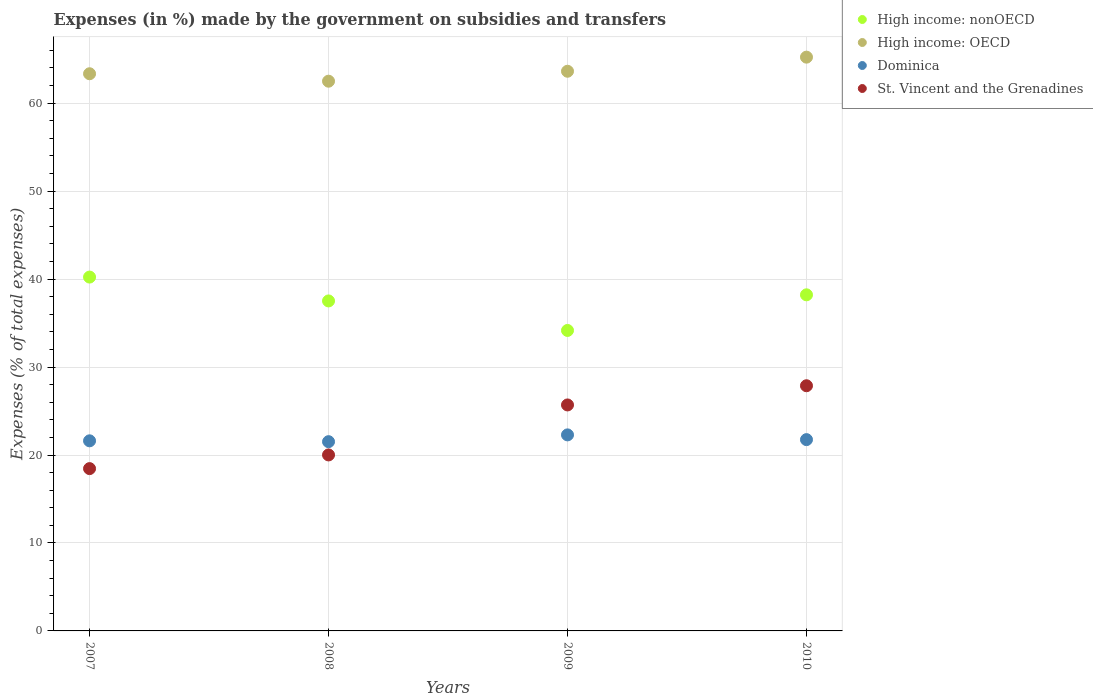What is the percentage of expenses made by the government on subsidies and transfers in St. Vincent and the Grenadines in 2010?
Your response must be concise. 27.87. Across all years, what is the maximum percentage of expenses made by the government on subsidies and transfers in High income: nonOECD?
Provide a succinct answer. 40.23. Across all years, what is the minimum percentage of expenses made by the government on subsidies and transfers in St. Vincent and the Grenadines?
Give a very brief answer. 18.45. In which year was the percentage of expenses made by the government on subsidies and transfers in High income: nonOECD minimum?
Your answer should be compact. 2009. What is the total percentage of expenses made by the government on subsidies and transfers in High income: OECD in the graph?
Your answer should be very brief. 254.71. What is the difference between the percentage of expenses made by the government on subsidies and transfers in High income: OECD in 2007 and that in 2008?
Provide a short and direct response. 0.85. What is the difference between the percentage of expenses made by the government on subsidies and transfers in Dominica in 2009 and the percentage of expenses made by the government on subsidies and transfers in High income: OECD in 2007?
Offer a terse response. -41.06. What is the average percentage of expenses made by the government on subsidies and transfers in High income: nonOECD per year?
Provide a succinct answer. 37.53. In the year 2007, what is the difference between the percentage of expenses made by the government on subsidies and transfers in High income: nonOECD and percentage of expenses made by the government on subsidies and transfers in Dominica?
Your answer should be compact. 18.62. In how many years, is the percentage of expenses made by the government on subsidies and transfers in High income: nonOECD greater than 64 %?
Your answer should be compact. 0. What is the ratio of the percentage of expenses made by the government on subsidies and transfers in Dominica in 2009 to that in 2010?
Keep it short and to the point. 1.02. Is the percentage of expenses made by the government on subsidies and transfers in St. Vincent and the Grenadines in 2007 less than that in 2009?
Your answer should be very brief. Yes. Is the difference between the percentage of expenses made by the government on subsidies and transfers in High income: nonOECD in 2008 and 2009 greater than the difference between the percentage of expenses made by the government on subsidies and transfers in Dominica in 2008 and 2009?
Give a very brief answer. Yes. What is the difference between the highest and the second highest percentage of expenses made by the government on subsidies and transfers in Dominica?
Your answer should be compact. 0.54. What is the difference between the highest and the lowest percentage of expenses made by the government on subsidies and transfers in High income: nonOECD?
Provide a succinct answer. 6.07. In how many years, is the percentage of expenses made by the government on subsidies and transfers in St. Vincent and the Grenadines greater than the average percentage of expenses made by the government on subsidies and transfers in St. Vincent and the Grenadines taken over all years?
Keep it short and to the point. 2. Is it the case that in every year, the sum of the percentage of expenses made by the government on subsidies and transfers in High income: OECD and percentage of expenses made by the government on subsidies and transfers in St. Vincent and the Grenadines  is greater than the sum of percentage of expenses made by the government on subsidies and transfers in Dominica and percentage of expenses made by the government on subsidies and transfers in High income: nonOECD?
Offer a terse response. Yes. Does the percentage of expenses made by the government on subsidies and transfers in Dominica monotonically increase over the years?
Your answer should be very brief. No. Is the percentage of expenses made by the government on subsidies and transfers in High income: nonOECD strictly less than the percentage of expenses made by the government on subsidies and transfers in Dominica over the years?
Offer a terse response. No. How many dotlines are there?
Your answer should be compact. 4. What is the difference between two consecutive major ticks on the Y-axis?
Give a very brief answer. 10. Does the graph contain any zero values?
Keep it short and to the point. No. Does the graph contain grids?
Keep it short and to the point. Yes. How many legend labels are there?
Ensure brevity in your answer.  4. How are the legend labels stacked?
Offer a very short reply. Vertical. What is the title of the graph?
Offer a very short reply. Expenses (in %) made by the government on subsidies and transfers. Does "Lesotho" appear as one of the legend labels in the graph?
Make the answer very short. No. What is the label or title of the X-axis?
Offer a terse response. Years. What is the label or title of the Y-axis?
Offer a terse response. Expenses (% of total expenses). What is the Expenses (% of total expenses) in High income: nonOECD in 2007?
Provide a short and direct response. 40.23. What is the Expenses (% of total expenses) in High income: OECD in 2007?
Your answer should be very brief. 63.35. What is the Expenses (% of total expenses) of Dominica in 2007?
Provide a succinct answer. 21.61. What is the Expenses (% of total expenses) in St. Vincent and the Grenadines in 2007?
Give a very brief answer. 18.45. What is the Expenses (% of total expenses) in High income: nonOECD in 2008?
Provide a short and direct response. 37.52. What is the Expenses (% of total expenses) in High income: OECD in 2008?
Your response must be concise. 62.5. What is the Expenses (% of total expenses) of Dominica in 2008?
Offer a very short reply. 21.52. What is the Expenses (% of total expenses) of St. Vincent and the Grenadines in 2008?
Your answer should be very brief. 20.01. What is the Expenses (% of total expenses) in High income: nonOECD in 2009?
Offer a terse response. 34.16. What is the Expenses (% of total expenses) of High income: OECD in 2009?
Your answer should be compact. 63.63. What is the Expenses (% of total expenses) in Dominica in 2009?
Offer a very short reply. 22.29. What is the Expenses (% of total expenses) in St. Vincent and the Grenadines in 2009?
Provide a short and direct response. 25.69. What is the Expenses (% of total expenses) in High income: nonOECD in 2010?
Make the answer very short. 38.21. What is the Expenses (% of total expenses) in High income: OECD in 2010?
Offer a very short reply. 65.23. What is the Expenses (% of total expenses) of Dominica in 2010?
Give a very brief answer. 21.75. What is the Expenses (% of total expenses) in St. Vincent and the Grenadines in 2010?
Offer a terse response. 27.87. Across all years, what is the maximum Expenses (% of total expenses) of High income: nonOECD?
Keep it short and to the point. 40.23. Across all years, what is the maximum Expenses (% of total expenses) of High income: OECD?
Make the answer very short. 65.23. Across all years, what is the maximum Expenses (% of total expenses) in Dominica?
Make the answer very short. 22.29. Across all years, what is the maximum Expenses (% of total expenses) in St. Vincent and the Grenadines?
Keep it short and to the point. 27.87. Across all years, what is the minimum Expenses (% of total expenses) of High income: nonOECD?
Your answer should be very brief. 34.16. Across all years, what is the minimum Expenses (% of total expenses) of High income: OECD?
Provide a succinct answer. 62.5. Across all years, what is the minimum Expenses (% of total expenses) of Dominica?
Your answer should be compact. 21.52. Across all years, what is the minimum Expenses (% of total expenses) of St. Vincent and the Grenadines?
Your answer should be compact. 18.45. What is the total Expenses (% of total expenses) in High income: nonOECD in the graph?
Your answer should be compact. 150.12. What is the total Expenses (% of total expenses) of High income: OECD in the graph?
Your answer should be very brief. 254.71. What is the total Expenses (% of total expenses) of Dominica in the graph?
Ensure brevity in your answer.  87.16. What is the total Expenses (% of total expenses) of St. Vincent and the Grenadines in the graph?
Make the answer very short. 92.03. What is the difference between the Expenses (% of total expenses) of High income: nonOECD in 2007 and that in 2008?
Your answer should be very brief. 2.71. What is the difference between the Expenses (% of total expenses) of High income: OECD in 2007 and that in 2008?
Offer a very short reply. 0.85. What is the difference between the Expenses (% of total expenses) in Dominica in 2007 and that in 2008?
Provide a short and direct response. 0.1. What is the difference between the Expenses (% of total expenses) in St. Vincent and the Grenadines in 2007 and that in 2008?
Offer a very short reply. -1.56. What is the difference between the Expenses (% of total expenses) in High income: nonOECD in 2007 and that in 2009?
Offer a very short reply. 6.07. What is the difference between the Expenses (% of total expenses) of High income: OECD in 2007 and that in 2009?
Make the answer very short. -0.28. What is the difference between the Expenses (% of total expenses) in Dominica in 2007 and that in 2009?
Provide a succinct answer. -0.68. What is the difference between the Expenses (% of total expenses) of St. Vincent and the Grenadines in 2007 and that in 2009?
Give a very brief answer. -7.24. What is the difference between the Expenses (% of total expenses) in High income: nonOECD in 2007 and that in 2010?
Provide a short and direct response. 2.02. What is the difference between the Expenses (% of total expenses) in High income: OECD in 2007 and that in 2010?
Give a very brief answer. -1.89. What is the difference between the Expenses (% of total expenses) in Dominica in 2007 and that in 2010?
Ensure brevity in your answer.  -0.14. What is the difference between the Expenses (% of total expenses) in St. Vincent and the Grenadines in 2007 and that in 2010?
Provide a succinct answer. -9.42. What is the difference between the Expenses (% of total expenses) of High income: nonOECD in 2008 and that in 2009?
Keep it short and to the point. 3.36. What is the difference between the Expenses (% of total expenses) in High income: OECD in 2008 and that in 2009?
Keep it short and to the point. -1.13. What is the difference between the Expenses (% of total expenses) in Dominica in 2008 and that in 2009?
Offer a terse response. -0.77. What is the difference between the Expenses (% of total expenses) of St. Vincent and the Grenadines in 2008 and that in 2009?
Provide a succinct answer. -5.68. What is the difference between the Expenses (% of total expenses) of High income: nonOECD in 2008 and that in 2010?
Your answer should be very brief. -0.69. What is the difference between the Expenses (% of total expenses) of High income: OECD in 2008 and that in 2010?
Ensure brevity in your answer.  -2.73. What is the difference between the Expenses (% of total expenses) of Dominica in 2008 and that in 2010?
Your answer should be compact. -0.23. What is the difference between the Expenses (% of total expenses) in St. Vincent and the Grenadines in 2008 and that in 2010?
Your answer should be very brief. -7.86. What is the difference between the Expenses (% of total expenses) of High income: nonOECD in 2009 and that in 2010?
Provide a short and direct response. -4.05. What is the difference between the Expenses (% of total expenses) in High income: OECD in 2009 and that in 2010?
Provide a succinct answer. -1.6. What is the difference between the Expenses (% of total expenses) in Dominica in 2009 and that in 2010?
Ensure brevity in your answer.  0.54. What is the difference between the Expenses (% of total expenses) of St. Vincent and the Grenadines in 2009 and that in 2010?
Keep it short and to the point. -2.18. What is the difference between the Expenses (% of total expenses) of High income: nonOECD in 2007 and the Expenses (% of total expenses) of High income: OECD in 2008?
Make the answer very short. -22.27. What is the difference between the Expenses (% of total expenses) of High income: nonOECD in 2007 and the Expenses (% of total expenses) of Dominica in 2008?
Offer a terse response. 18.71. What is the difference between the Expenses (% of total expenses) of High income: nonOECD in 2007 and the Expenses (% of total expenses) of St. Vincent and the Grenadines in 2008?
Your response must be concise. 20.22. What is the difference between the Expenses (% of total expenses) in High income: OECD in 2007 and the Expenses (% of total expenses) in Dominica in 2008?
Offer a very short reply. 41.83. What is the difference between the Expenses (% of total expenses) of High income: OECD in 2007 and the Expenses (% of total expenses) of St. Vincent and the Grenadines in 2008?
Make the answer very short. 43.34. What is the difference between the Expenses (% of total expenses) in Dominica in 2007 and the Expenses (% of total expenses) in St. Vincent and the Grenadines in 2008?
Offer a terse response. 1.6. What is the difference between the Expenses (% of total expenses) in High income: nonOECD in 2007 and the Expenses (% of total expenses) in High income: OECD in 2009?
Your response must be concise. -23.4. What is the difference between the Expenses (% of total expenses) in High income: nonOECD in 2007 and the Expenses (% of total expenses) in Dominica in 2009?
Keep it short and to the point. 17.94. What is the difference between the Expenses (% of total expenses) in High income: nonOECD in 2007 and the Expenses (% of total expenses) in St. Vincent and the Grenadines in 2009?
Make the answer very short. 14.54. What is the difference between the Expenses (% of total expenses) in High income: OECD in 2007 and the Expenses (% of total expenses) in Dominica in 2009?
Provide a short and direct response. 41.06. What is the difference between the Expenses (% of total expenses) in High income: OECD in 2007 and the Expenses (% of total expenses) in St. Vincent and the Grenadines in 2009?
Your response must be concise. 37.65. What is the difference between the Expenses (% of total expenses) of Dominica in 2007 and the Expenses (% of total expenses) of St. Vincent and the Grenadines in 2009?
Offer a terse response. -4.08. What is the difference between the Expenses (% of total expenses) of High income: nonOECD in 2007 and the Expenses (% of total expenses) of High income: OECD in 2010?
Give a very brief answer. -25. What is the difference between the Expenses (% of total expenses) in High income: nonOECD in 2007 and the Expenses (% of total expenses) in Dominica in 2010?
Your response must be concise. 18.48. What is the difference between the Expenses (% of total expenses) in High income: nonOECD in 2007 and the Expenses (% of total expenses) in St. Vincent and the Grenadines in 2010?
Your answer should be very brief. 12.36. What is the difference between the Expenses (% of total expenses) of High income: OECD in 2007 and the Expenses (% of total expenses) of Dominica in 2010?
Your answer should be compact. 41.6. What is the difference between the Expenses (% of total expenses) in High income: OECD in 2007 and the Expenses (% of total expenses) in St. Vincent and the Grenadines in 2010?
Your answer should be compact. 35.47. What is the difference between the Expenses (% of total expenses) in Dominica in 2007 and the Expenses (% of total expenses) in St. Vincent and the Grenadines in 2010?
Your answer should be compact. -6.26. What is the difference between the Expenses (% of total expenses) of High income: nonOECD in 2008 and the Expenses (% of total expenses) of High income: OECD in 2009?
Ensure brevity in your answer.  -26.11. What is the difference between the Expenses (% of total expenses) in High income: nonOECD in 2008 and the Expenses (% of total expenses) in Dominica in 2009?
Your answer should be compact. 15.23. What is the difference between the Expenses (% of total expenses) in High income: nonOECD in 2008 and the Expenses (% of total expenses) in St. Vincent and the Grenadines in 2009?
Offer a very short reply. 11.83. What is the difference between the Expenses (% of total expenses) in High income: OECD in 2008 and the Expenses (% of total expenses) in Dominica in 2009?
Make the answer very short. 40.21. What is the difference between the Expenses (% of total expenses) of High income: OECD in 2008 and the Expenses (% of total expenses) of St. Vincent and the Grenadines in 2009?
Offer a very short reply. 36.81. What is the difference between the Expenses (% of total expenses) in Dominica in 2008 and the Expenses (% of total expenses) in St. Vincent and the Grenadines in 2009?
Make the answer very short. -4.18. What is the difference between the Expenses (% of total expenses) of High income: nonOECD in 2008 and the Expenses (% of total expenses) of High income: OECD in 2010?
Your answer should be compact. -27.72. What is the difference between the Expenses (% of total expenses) in High income: nonOECD in 2008 and the Expenses (% of total expenses) in Dominica in 2010?
Your response must be concise. 15.77. What is the difference between the Expenses (% of total expenses) in High income: nonOECD in 2008 and the Expenses (% of total expenses) in St. Vincent and the Grenadines in 2010?
Give a very brief answer. 9.64. What is the difference between the Expenses (% of total expenses) in High income: OECD in 2008 and the Expenses (% of total expenses) in Dominica in 2010?
Keep it short and to the point. 40.75. What is the difference between the Expenses (% of total expenses) of High income: OECD in 2008 and the Expenses (% of total expenses) of St. Vincent and the Grenadines in 2010?
Provide a short and direct response. 34.63. What is the difference between the Expenses (% of total expenses) of Dominica in 2008 and the Expenses (% of total expenses) of St. Vincent and the Grenadines in 2010?
Your answer should be very brief. -6.36. What is the difference between the Expenses (% of total expenses) of High income: nonOECD in 2009 and the Expenses (% of total expenses) of High income: OECD in 2010?
Provide a short and direct response. -31.07. What is the difference between the Expenses (% of total expenses) of High income: nonOECD in 2009 and the Expenses (% of total expenses) of Dominica in 2010?
Keep it short and to the point. 12.41. What is the difference between the Expenses (% of total expenses) of High income: nonOECD in 2009 and the Expenses (% of total expenses) of St. Vincent and the Grenadines in 2010?
Your answer should be compact. 6.29. What is the difference between the Expenses (% of total expenses) of High income: OECD in 2009 and the Expenses (% of total expenses) of Dominica in 2010?
Offer a very short reply. 41.88. What is the difference between the Expenses (% of total expenses) of High income: OECD in 2009 and the Expenses (% of total expenses) of St. Vincent and the Grenadines in 2010?
Provide a short and direct response. 35.76. What is the difference between the Expenses (% of total expenses) in Dominica in 2009 and the Expenses (% of total expenses) in St. Vincent and the Grenadines in 2010?
Give a very brief answer. -5.59. What is the average Expenses (% of total expenses) of High income: nonOECD per year?
Your response must be concise. 37.53. What is the average Expenses (% of total expenses) in High income: OECD per year?
Your answer should be compact. 63.68. What is the average Expenses (% of total expenses) in Dominica per year?
Your response must be concise. 21.79. What is the average Expenses (% of total expenses) of St. Vincent and the Grenadines per year?
Provide a succinct answer. 23.01. In the year 2007, what is the difference between the Expenses (% of total expenses) in High income: nonOECD and Expenses (% of total expenses) in High income: OECD?
Ensure brevity in your answer.  -23.12. In the year 2007, what is the difference between the Expenses (% of total expenses) in High income: nonOECD and Expenses (% of total expenses) in Dominica?
Offer a very short reply. 18.62. In the year 2007, what is the difference between the Expenses (% of total expenses) of High income: nonOECD and Expenses (% of total expenses) of St. Vincent and the Grenadines?
Offer a very short reply. 21.78. In the year 2007, what is the difference between the Expenses (% of total expenses) of High income: OECD and Expenses (% of total expenses) of Dominica?
Provide a succinct answer. 41.73. In the year 2007, what is the difference between the Expenses (% of total expenses) of High income: OECD and Expenses (% of total expenses) of St. Vincent and the Grenadines?
Your answer should be compact. 44.89. In the year 2007, what is the difference between the Expenses (% of total expenses) in Dominica and Expenses (% of total expenses) in St. Vincent and the Grenadines?
Your response must be concise. 3.16. In the year 2008, what is the difference between the Expenses (% of total expenses) in High income: nonOECD and Expenses (% of total expenses) in High income: OECD?
Ensure brevity in your answer.  -24.98. In the year 2008, what is the difference between the Expenses (% of total expenses) in High income: nonOECD and Expenses (% of total expenses) in Dominica?
Offer a terse response. 16. In the year 2008, what is the difference between the Expenses (% of total expenses) of High income: nonOECD and Expenses (% of total expenses) of St. Vincent and the Grenadines?
Your answer should be compact. 17.51. In the year 2008, what is the difference between the Expenses (% of total expenses) of High income: OECD and Expenses (% of total expenses) of Dominica?
Give a very brief answer. 40.98. In the year 2008, what is the difference between the Expenses (% of total expenses) of High income: OECD and Expenses (% of total expenses) of St. Vincent and the Grenadines?
Offer a terse response. 42.49. In the year 2008, what is the difference between the Expenses (% of total expenses) in Dominica and Expenses (% of total expenses) in St. Vincent and the Grenadines?
Your answer should be very brief. 1.51. In the year 2009, what is the difference between the Expenses (% of total expenses) in High income: nonOECD and Expenses (% of total expenses) in High income: OECD?
Offer a terse response. -29.47. In the year 2009, what is the difference between the Expenses (% of total expenses) of High income: nonOECD and Expenses (% of total expenses) of Dominica?
Make the answer very short. 11.87. In the year 2009, what is the difference between the Expenses (% of total expenses) in High income: nonOECD and Expenses (% of total expenses) in St. Vincent and the Grenadines?
Your answer should be compact. 8.47. In the year 2009, what is the difference between the Expenses (% of total expenses) of High income: OECD and Expenses (% of total expenses) of Dominica?
Your answer should be compact. 41.34. In the year 2009, what is the difference between the Expenses (% of total expenses) in High income: OECD and Expenses (% of total expenses) in St. Vincent and the Grenadines?
Provide a succinct answer. 37.94. In the year 2009, what is the difference between the Expenses (% of total expenses) in Dominica and Expenses (% of total expenses) in St. Vincent and the Grenadines?
Your answer should be very brief. -3.4. In the year 2010, what is the difference between the Expenses (% of total expenses) in High income: nonOECD and Expenses (% of total expenses) in High income: OECD?
Make the answer very short. -27.02. In the year 2010, what is the difference between the Expenses (% of total expenses) of High income: nonOECD and Expenses (% of total expenses) of Dominica?
Offer a terse response. 16.46. In the year 2010, what is the difference between the Expenses (% of total expenses) in High income: nonOECD and Expenses (% of total expenses) in St. Vincent and the Grenadines?
Provide a short and direct response. 10.34. In the year 2010, what is the difference between the Expenses (% of total expenses) in High income: OECD and Expenses (% of total expenses) in Dominica?
Offer a very short reply. 43.48. In the year 2010, what is the difference between the Expenses (% of total expenses) in High income: OECD and Expenses (% of total expenses) in St. Vincent and the Grenadines?
Ensure brevity in your answer.  37.36. In the year 2010, what is the difference between the Expenses (% of total expenses) of Dominica and Expenses (% of total expenses) of St. Vincent and the Grenadines?
Keep it short and to the point. -6.13. What is the ratio of the Expenses (% of total expenses) in High income: nonOECD in 2007 to that in 2008?
Your answer should be very brief. 1.07. What is the ratio of the Expenses (% of total expenses) in High income: OECD in 2007 to that in 2008?
Offer a terse response. 1.01. What is the ratio of the Expenses (% of total expenses) in St. Vincent and the Grenadines in 2007 to that in 2008?
Provide a succinct answer. 0.92. What is the ratio of the Expenses (% of total expenses) of High income: nonOECD in 2007 to that in 2009?
Provide a short and direct response. 1.18. What is the ratio of the Expenses (% of total expenses) in High income: OECD in 2007 to that in 2009?
Ensure brevity in your answer.  1. What is the ratio of the Expenses (% of total expenses) of Dominica in 2007 to that in 2009?
Your answer should be compact. 0.97. What is the ratio of the Expenses (% of total expenses) of St. Vincent and the Grenadines in 2007 to that in 2009?
Provide a short and direct response. 0.72. What is the ratio of the Expenses (% of total expenses) in High income: nonOECD in 2007 to that in 2010?
Your response must be concise. 1.05. What is the ratio of the Expenses (% of total expenses) of High income: OECD in 2007 to that in 2010?
Give a very brief answer. 0.97. What is the ratio of the Expenses (% of total expenses) in St. Vincent and the Grenadines in 2007 to that in 2010?
Your answer should be very brief. 0.66. What is the ratio of the Expenses (% of total expenses) in High income: nonOECD in 2008 to that in 2009?
Give a very brief answer. 1.1. What is the ratio of the Expenses (% of total expenses) of High income: OECD in 2008 to that in 2009?
Provide a succinct answer. 0.98. What is the ratio of the Expenses (% of total expenses) of Dominica in 2008 to that in 2009?
Provide a short and direct response. 0.97. What is the ratio of the Expenses (% of total expenses) in St. Vincent and the Grenadines in 2008 to that in 2009?
Make the answer very short. 0.78. What is the ratio of the Expenses (% of total expenses) in High income: nonOECD in 2008 to that in 2010?
Give a very brief answer. 0.98. What is the ratio of the Expenses (% of total expenses) in High income: OECD in 2008 to that in 2010?
Offer a terse response. 0.96. What is the ratio of the Expenses (% of total expenses) of Dominica in 2008 to that in 2010?
Ensure brevity in your answer.  0.99. What is the ratio of the Expenses (% of total expenses) of St. Vincent and the Grenadines in 2008 to that in 2010?
Provide a short and direct response. 0.72. What is the ratio of the Expenses (% of total expenses) of High income: nonOECD in 2009 to that in 2010?
Ensure brevity in your answer.  0.89. What is the ratio of the Expenses (% of total expenses) of High income: OECD in 2009 to that in 2010?
Offer a very short reply. 0.98. What is the ratio of the Expenses (% of total expenses) of Dominica in 2009 to that in 2010?
Offer a very short reply. 1.02. What is the ratio of the Expenses (% of total expenses) in St. Vincent and the Grenadines in 2009 to that in 2010?
Provide a short and direct response. 0.92. What is the difference between the highest and the second highest Expenses (% of total expenses) in High income: nonOECD?
Your answer should be very brief. 2.02. What is the difference between the highest and the second highest Expenses (% of total expenses) of High income: OECD?
Offer a terse response. 1.6. What is the difference between the highest and the second highest Expenses (% of total expenses) of Dominica?
Offer a terse response. 0.54. What is the difference between the highest and the second highest Expenses (% of total expenses) in St. Vincent and the Grenadines?
Offer a very short reply. 2.18. What is the difference between the highest and the lowest Expenses (% of total expenses) in High income: nonOECD?
Your answer should be compact. 6.07. What is the difference between the highest and the lowest Expenses (% of total expenses) in High income: OECD?
Offer a terse response. 2.73. What is the difference between the highest and the lowest Expenses (% of total expenses) of Dominica?
Offer a very short reply. 0.77. What is the difference between the highest and the lowest Expenses (% of total expenses) in St. Vincent and the Grenadines?
Your response must be concise. 9.42. 